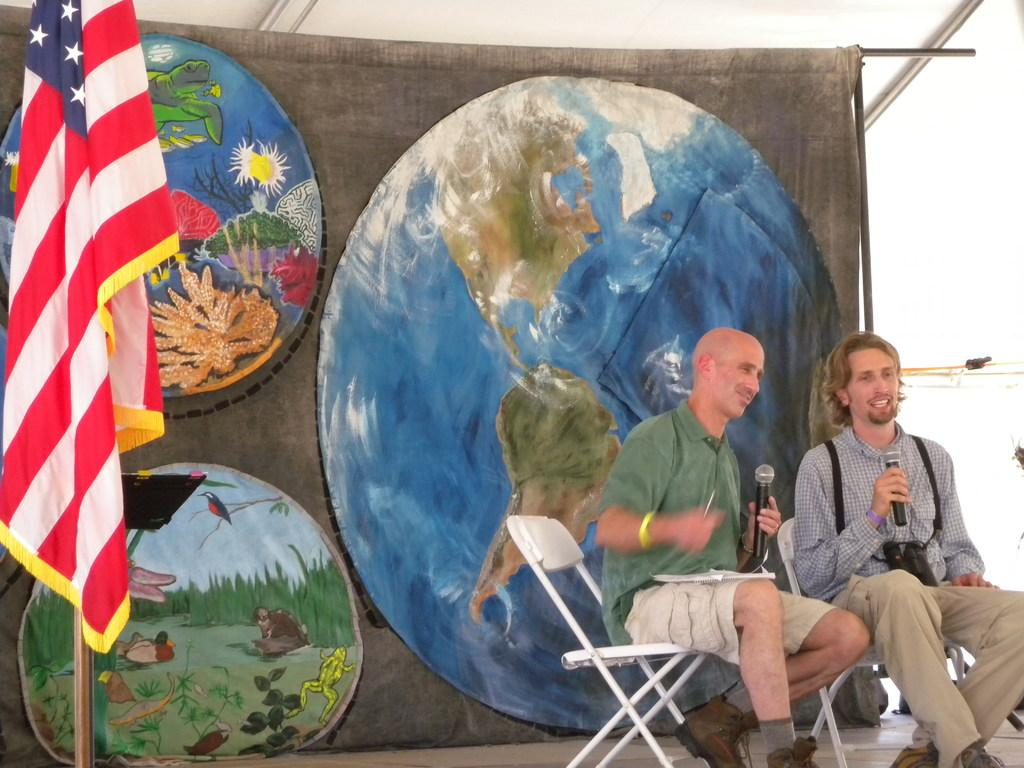How many people are in the image? There are two men in the image. What are the men doing in the image? The men are sitting on chairs and holding microphones. What can be seen in the background of the image? There is a banner, a stand, and a flag visible in the image. What type of twist can be seen in the image? There is no twist present in the image. Is it raining in the image? The image does not show any indication of rain. 